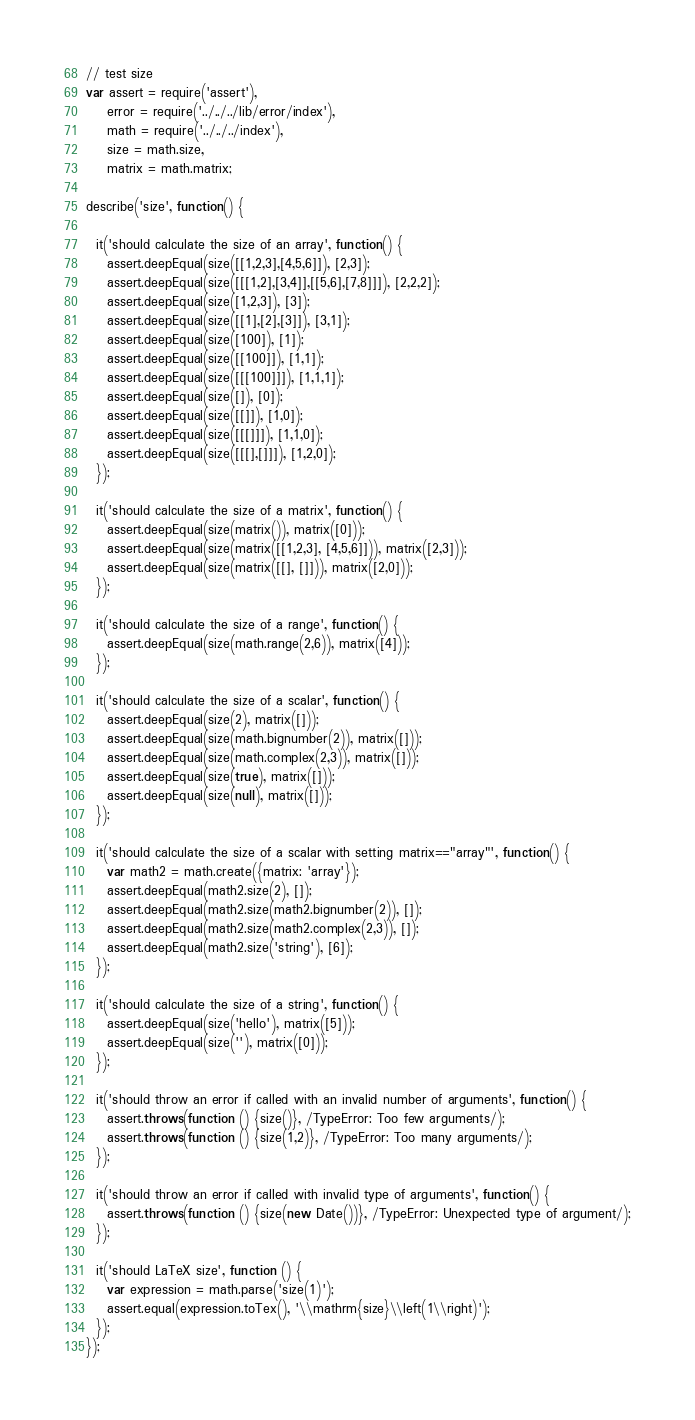Convert code to text. <code><loc_0><loc_0><loc_500><loc_500><_JavaScript_>// test size
var assert = require('assert'),
    error = require('../../../lib/error/index'),
    math = require('../../../index'),
    size = math.size,
    matrix = math.matrix;

describe('size', function() {

  it('should calculate the size of an array', function() {
    assert.deepEqual(size([[1,2,3],[4,5,6]]), [2,3]);
    assert.deepEqual(size([[[1,2],[3,4]],[[5,6],[7,8]]]), [2,2,2]);
    assert.deepEqual(size([1,2,3]), [3]);
    assert.deepEqual(size([[1],[2],[3]]), [3,1]);
    assert.deepEqual(size([100]), [1]);
    assert.deepEqual(size([[100]]), [1,1]);
    assert.deepEqual(size([[[100]]]), [1,1,1]);
    assert.deepEqual(size([]), [0]);
    assert.deepEqual(size([[]]), [1,0]);
    assert.deepEqual(size([[[]]]), [1,1,0]);
    assert.deepEqual(size([[[],[]]]), [1,2,0]);
  });

  it('should calculate the size of a matrix', function() {
    assert.deepEqual(size(matrix()), matrix([0]));
    assert.deepEqual(size(matrix([[1,2,3], [4,5,6]])), matrix([2,3]));
    assert.deepEqual(size(matrix([[], []])), matrix([2,0]));
  });

  it('should calculate the size of a range', function() {
    assert.deepEqual(size(math.range(2,6)), matrix([4]));
  });

  it('should calculate the size of a scalar', function() {
    assert.deepEqual(size(2), matrix([]));
    assert.deepEqual(size(math.bignumber(2)), matrix([]));
    assert.deepEqual(size(math.complex(2,3)), matrix([]));
    assert.deepEqual(size(true), matrix([]));
    assert.deepEqual(size(null), matrix([]));
  });

  it('should calculate the size of a scalar with setting matrix=="array"', function() {
    var math2 = math.create({matrix: 'array'});
    assert.deepEqual(math2.size(2), []);
    assert.deepEqual(math2.size(math2.bignumber(2)), []);
    assert.deepEqual(math2.size(math2.complex(2,3)), []);
    assert.deepEqual(math2.size('string'), [6]);
  });

  it('should calculate the size of a string', function() {
    assert.deepEqual(size('hello'), matrix([5]));
    assert.deepEqual(size(''), matrix([0]));
  });

  it('should throw an error if called with an invalid number of arguments', function() {
    assert.throws(function () {size()}, /TypeError: Too few arguments/);
    assert.throws(function () {size(1,2)}, /TypeError: Too many arguments/);
  });

  it('should throw an error if called with invalid type of arguments', function() {
    assert.throws(function () {size(new Date())}, /TypeError: Unexpected type of argument/);
  });

  it('should LaTeX size', function () {
    var expression = math.parse('size(1)');
    assert.equal(expression.toTex(), '\\mathrm{size}\\left(1\\right)');
  });
});
</code> 